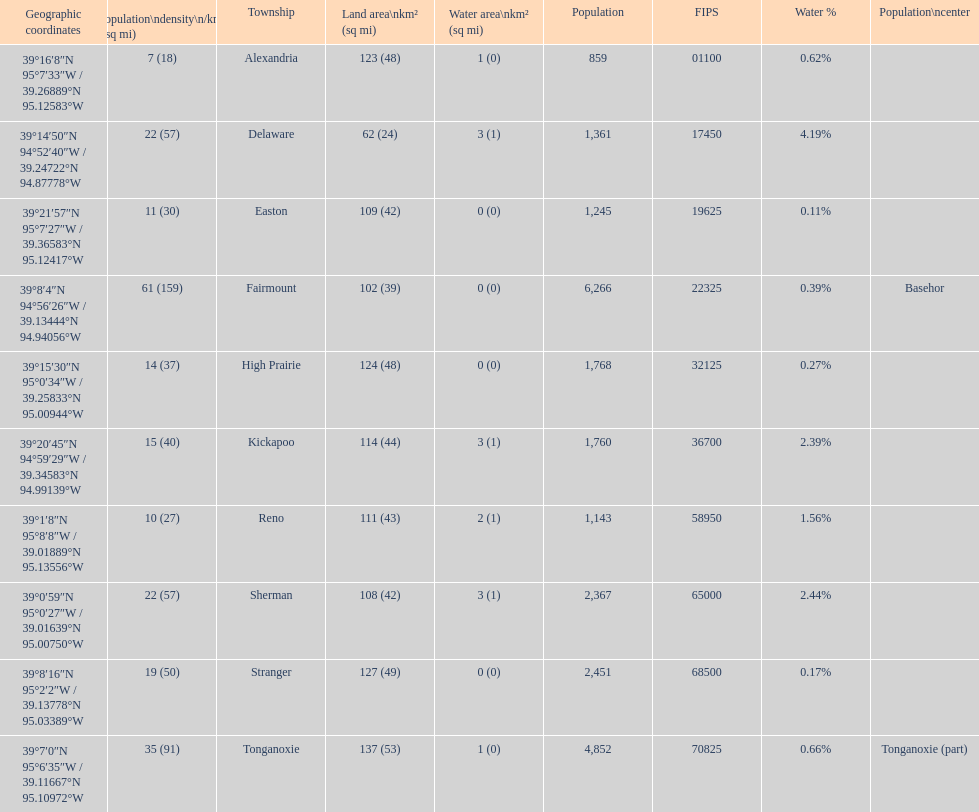What township has the most land area? Tonganoxie. 